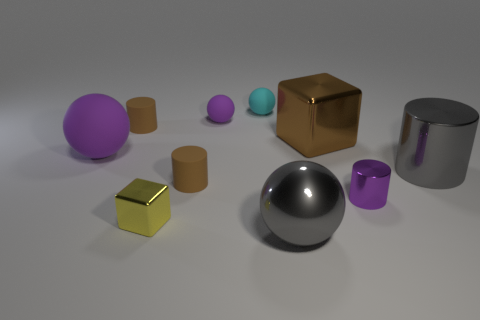Subtract all gray cylinders. How many cylinders are left? 3 Subtract all purple cylinders. How many cylinders are left? 3 Subtract all blocks. How many objects are left? 8 Subtract all purple cylinders. Subtract all blue balls. How many cylinders are left? 3 Subtract all yellow cylinders. How many green balls are left? 0 Subtract all big brown rubber things. Subtract all cyan spheres. How many objects are left? 9 Add 7 big shiny objects. How many big shiny objects are left? 10 Add 8 brown rubber cylinders. How many brown rubber cylinders exist? 10 Subtract 0 blue cylinders. How many objects are left? 10 Subtract 3 spheres. How many spheres are left? 1 